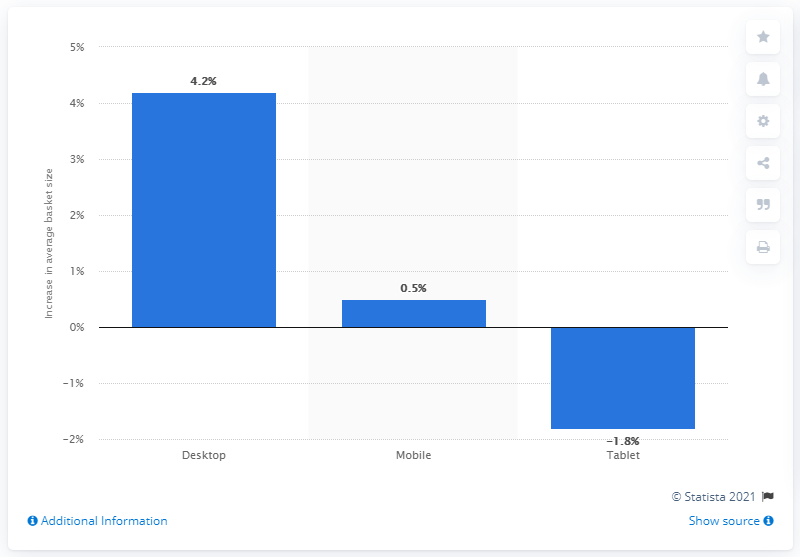What was the increase in desktop computers from 2015 to 2016? The increase in desktop computer usage from 2015 to 2016 was 4.2%, as depicted by the bar chart, indicating a growth in adoption or preference for desktop computing during that period. 